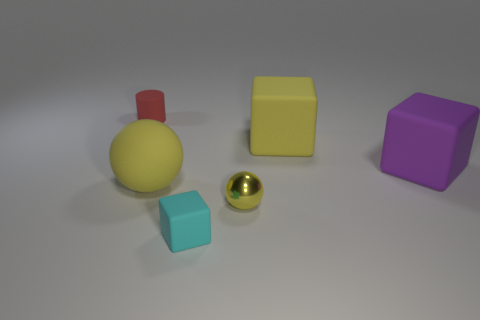There is a small matte thing in front of the matte thing left of the yellow rubber sphere; is there a big purple matte cube that is in front of it?
Keep it short and to the point. No. Does the metal object have the same color as the rubber ball?
Your response must be concise. Yes. What is the color of the block in front of the yellow sphere that is on the right side of the small cyan object?
Give a very brief answer. Cyan. How many small objects are either cylinders or cyan matte things?
Offer a terse response. 2. The thing that is behind the purple object and to the right of the small cylinder is what color?
Offer a very short reply. Yellow. Is the tiny ball made of the same material as the tiny cyan block?
Your answer should be very brief. No. The purple matte object has what shape?
Your response must be concise. Cube. There is a small object right of the tiny rubber thing that is in front of the purple rubber cube; what number of purple rubber blocks are behind it?
Your answer should be compact. 1. What color is the other small thing that is the same shape as the purple thing?
Ensure brevity in your answer.  Cyan. There is a big yellow matte object on the right side of the yellow sphere that is to the right of the cube in front of the tiny ball; what is its shape?
Offer a terse response. Cube. 